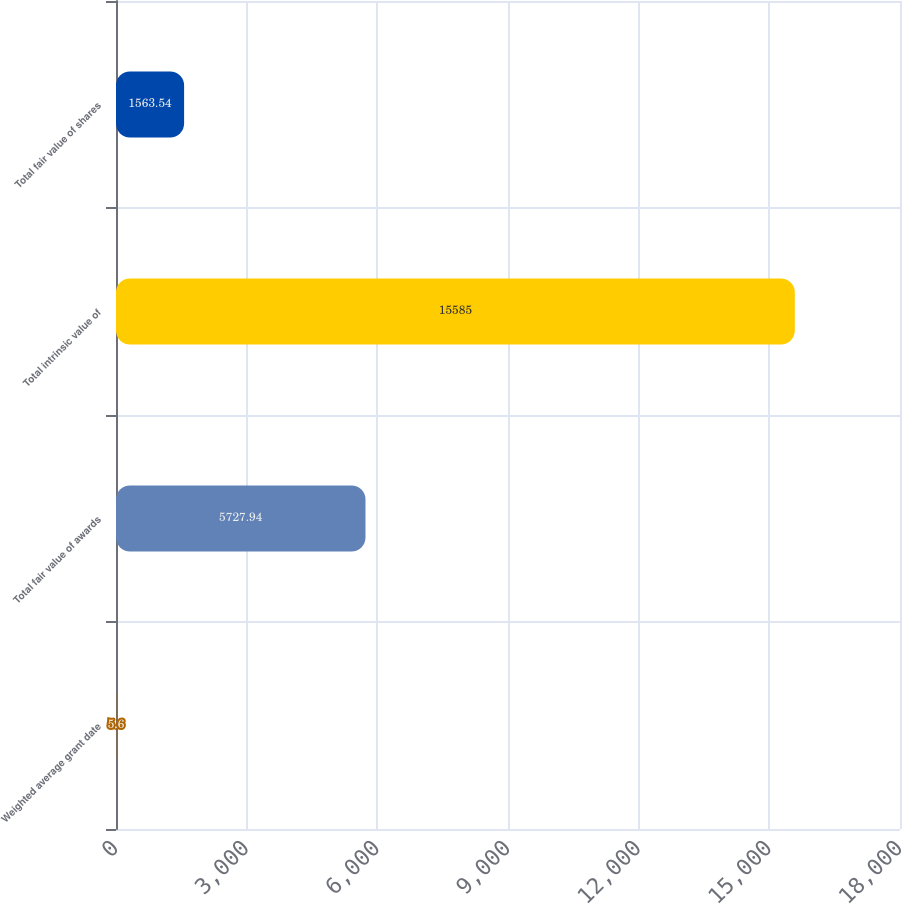Convert chart. <chart><loc_0><loc_0><loc_500><loc_500><bar_chart><fcel>Weighted average grant date<fcel>Total fair value of awards<fcel>Total intrinsic value of<fcel>Total fair value of shares<nl><fcel>5.6<fcel>5727.94<fcel>15585<fcel>1563.54<nl></chart> 